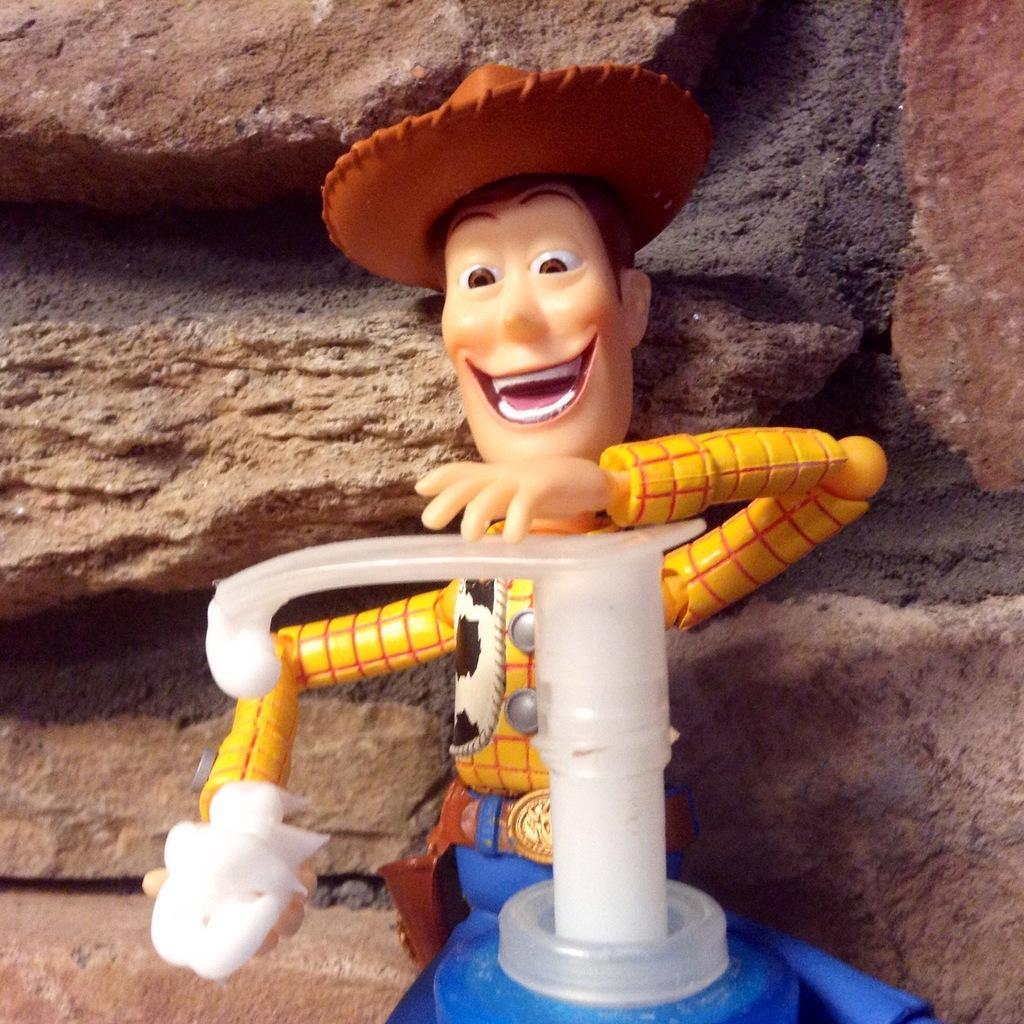Please provide a concise description of this image. In this image, we can see a toy and an object. In the background, there are rocks. 